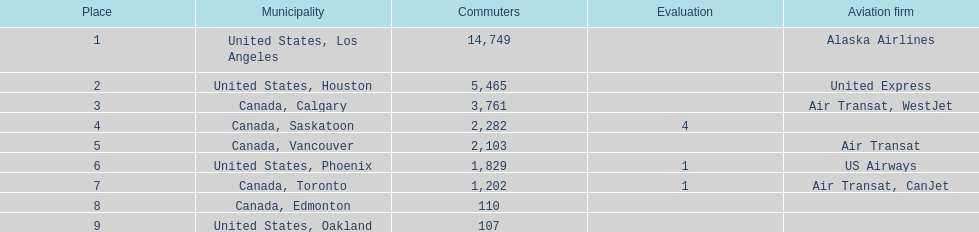How many more passengers flew to los angeles than to saskatoon from manzanillo airport in 2013? 12,467. 